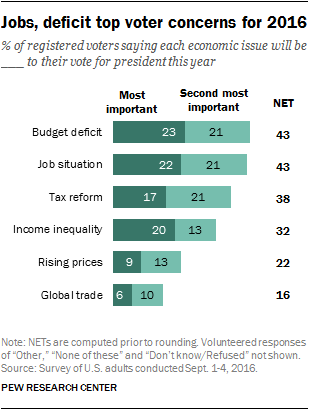Give some essential details in this illustration. Out of the total number of voters surveyed, a majority chose the most important issue, with 3 exceeding the number of voters who chose the second most important issue. The percentage of voters choosing the most important issue for tax reform is 17%. 